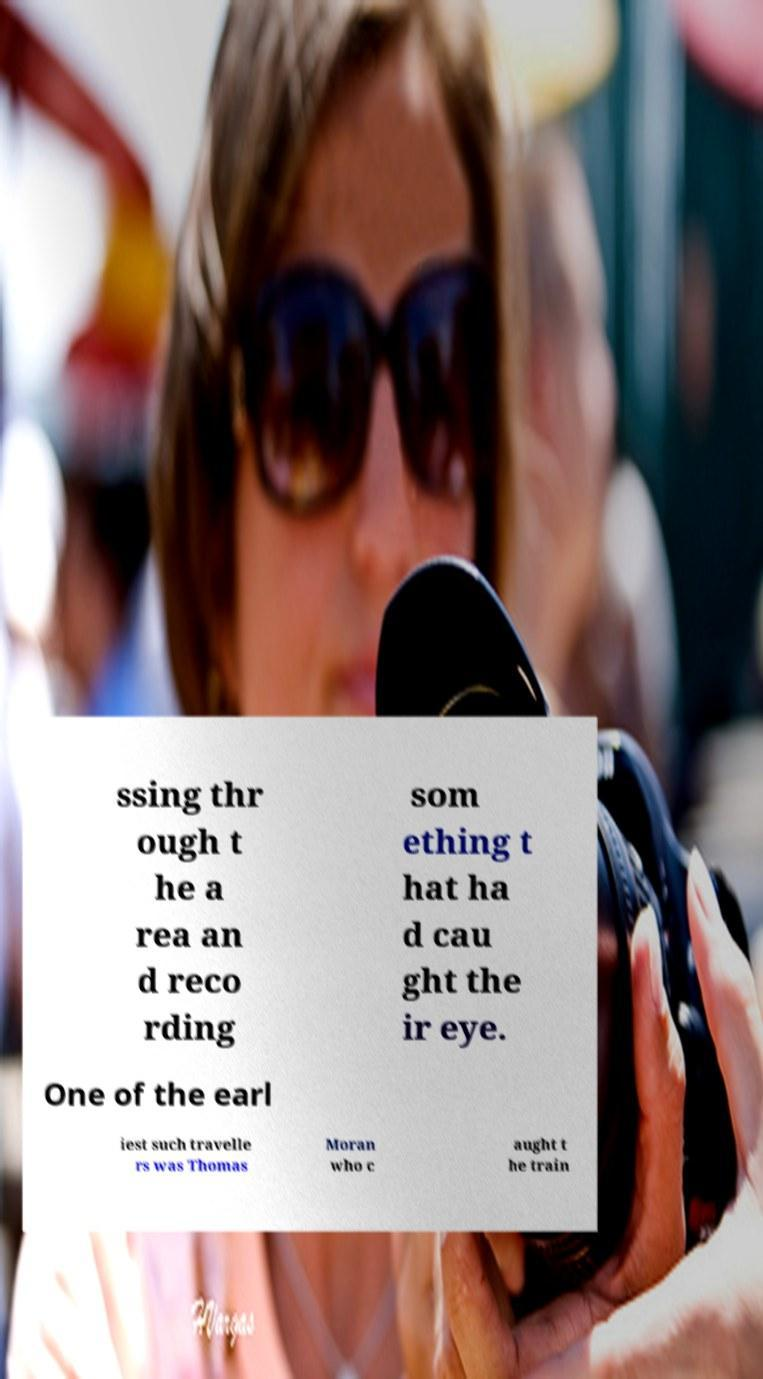There's text embedded in this image that I need extracted. Can you transcribe it verbatim? ssing thr ough t he a rea an d reco rding som ething t hat ha d cau ght the ir eye. One of the earl iest such travelle rs was Thomas Moran who c aught t he train 